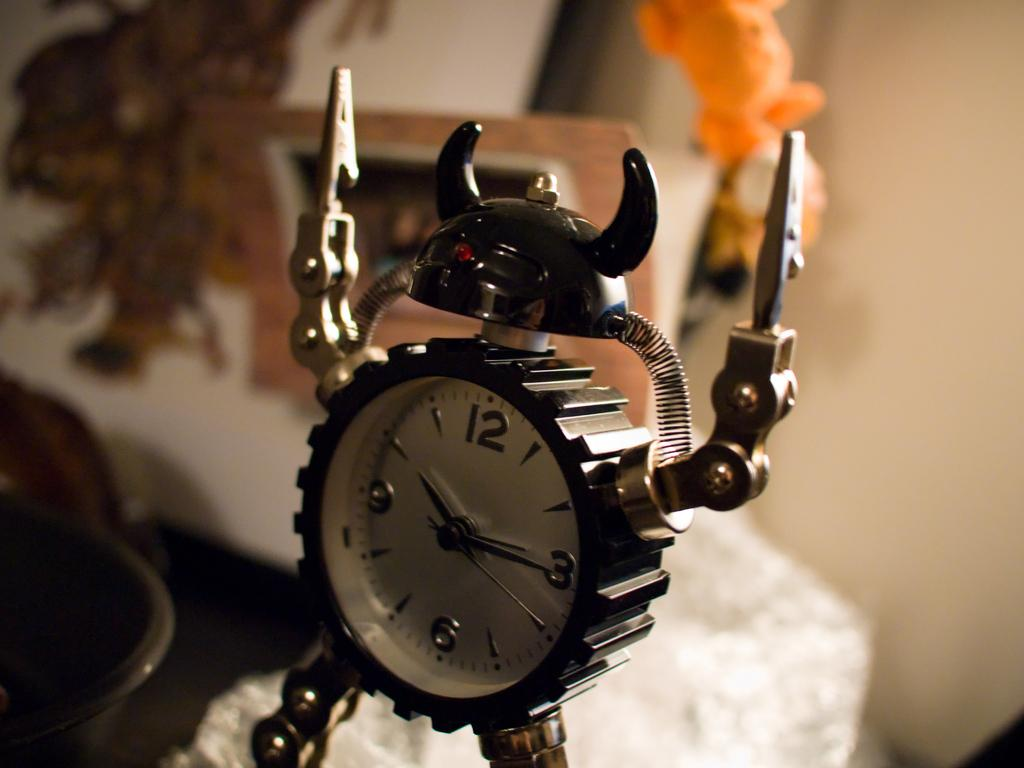<image>
Share a concise interpretation of the image provided. A clock shaped like a robot shows that the time is now almost 10:15. 